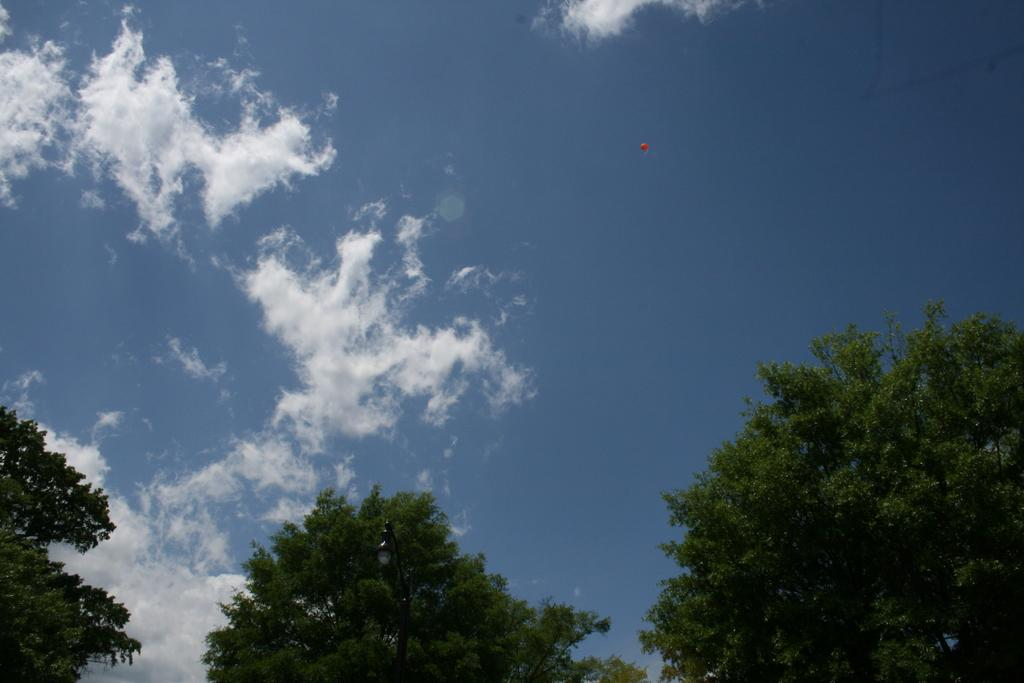What can be seen in the background of the image? The sky is visible in the image. What is the condition of the sky in the image? There are clouds in the sky. What type of vegetation is present in the image? Trees are present in the image. How many organizations can be seen in the image? There are no organizations present in the image. Can you describe the jumping technique of the trees in the image? There is no jumping technique for the trees in the image, as trees do not have the ability to jump. 